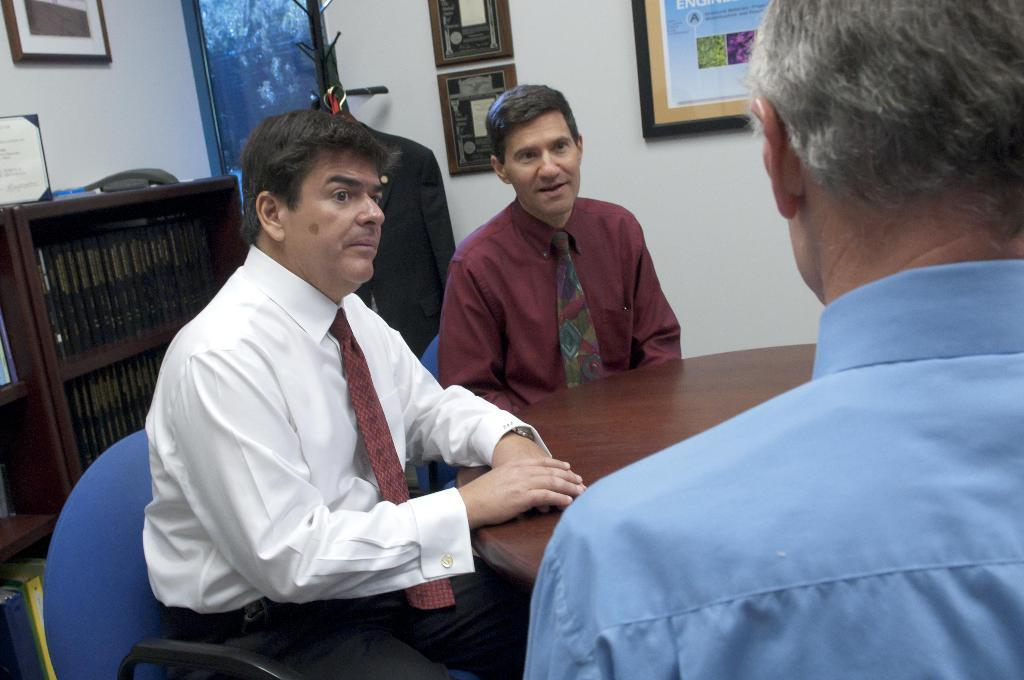What are the people in the image doing? The people in the image are sitting on chairs. Where are the chairs located in relation to the table? The chairs are in front of a table. What can be seen on the wall in the image? There are frames on the wall in the image. What type of mist can be seen surrounding the people in the image? There is no mist present in the image; it features people sitting on chairs in front of a table with frames on the wall. 